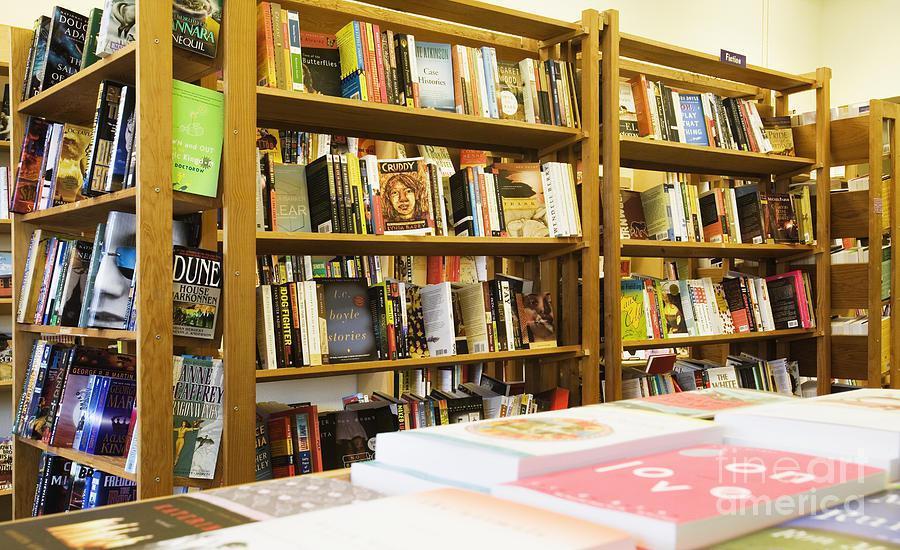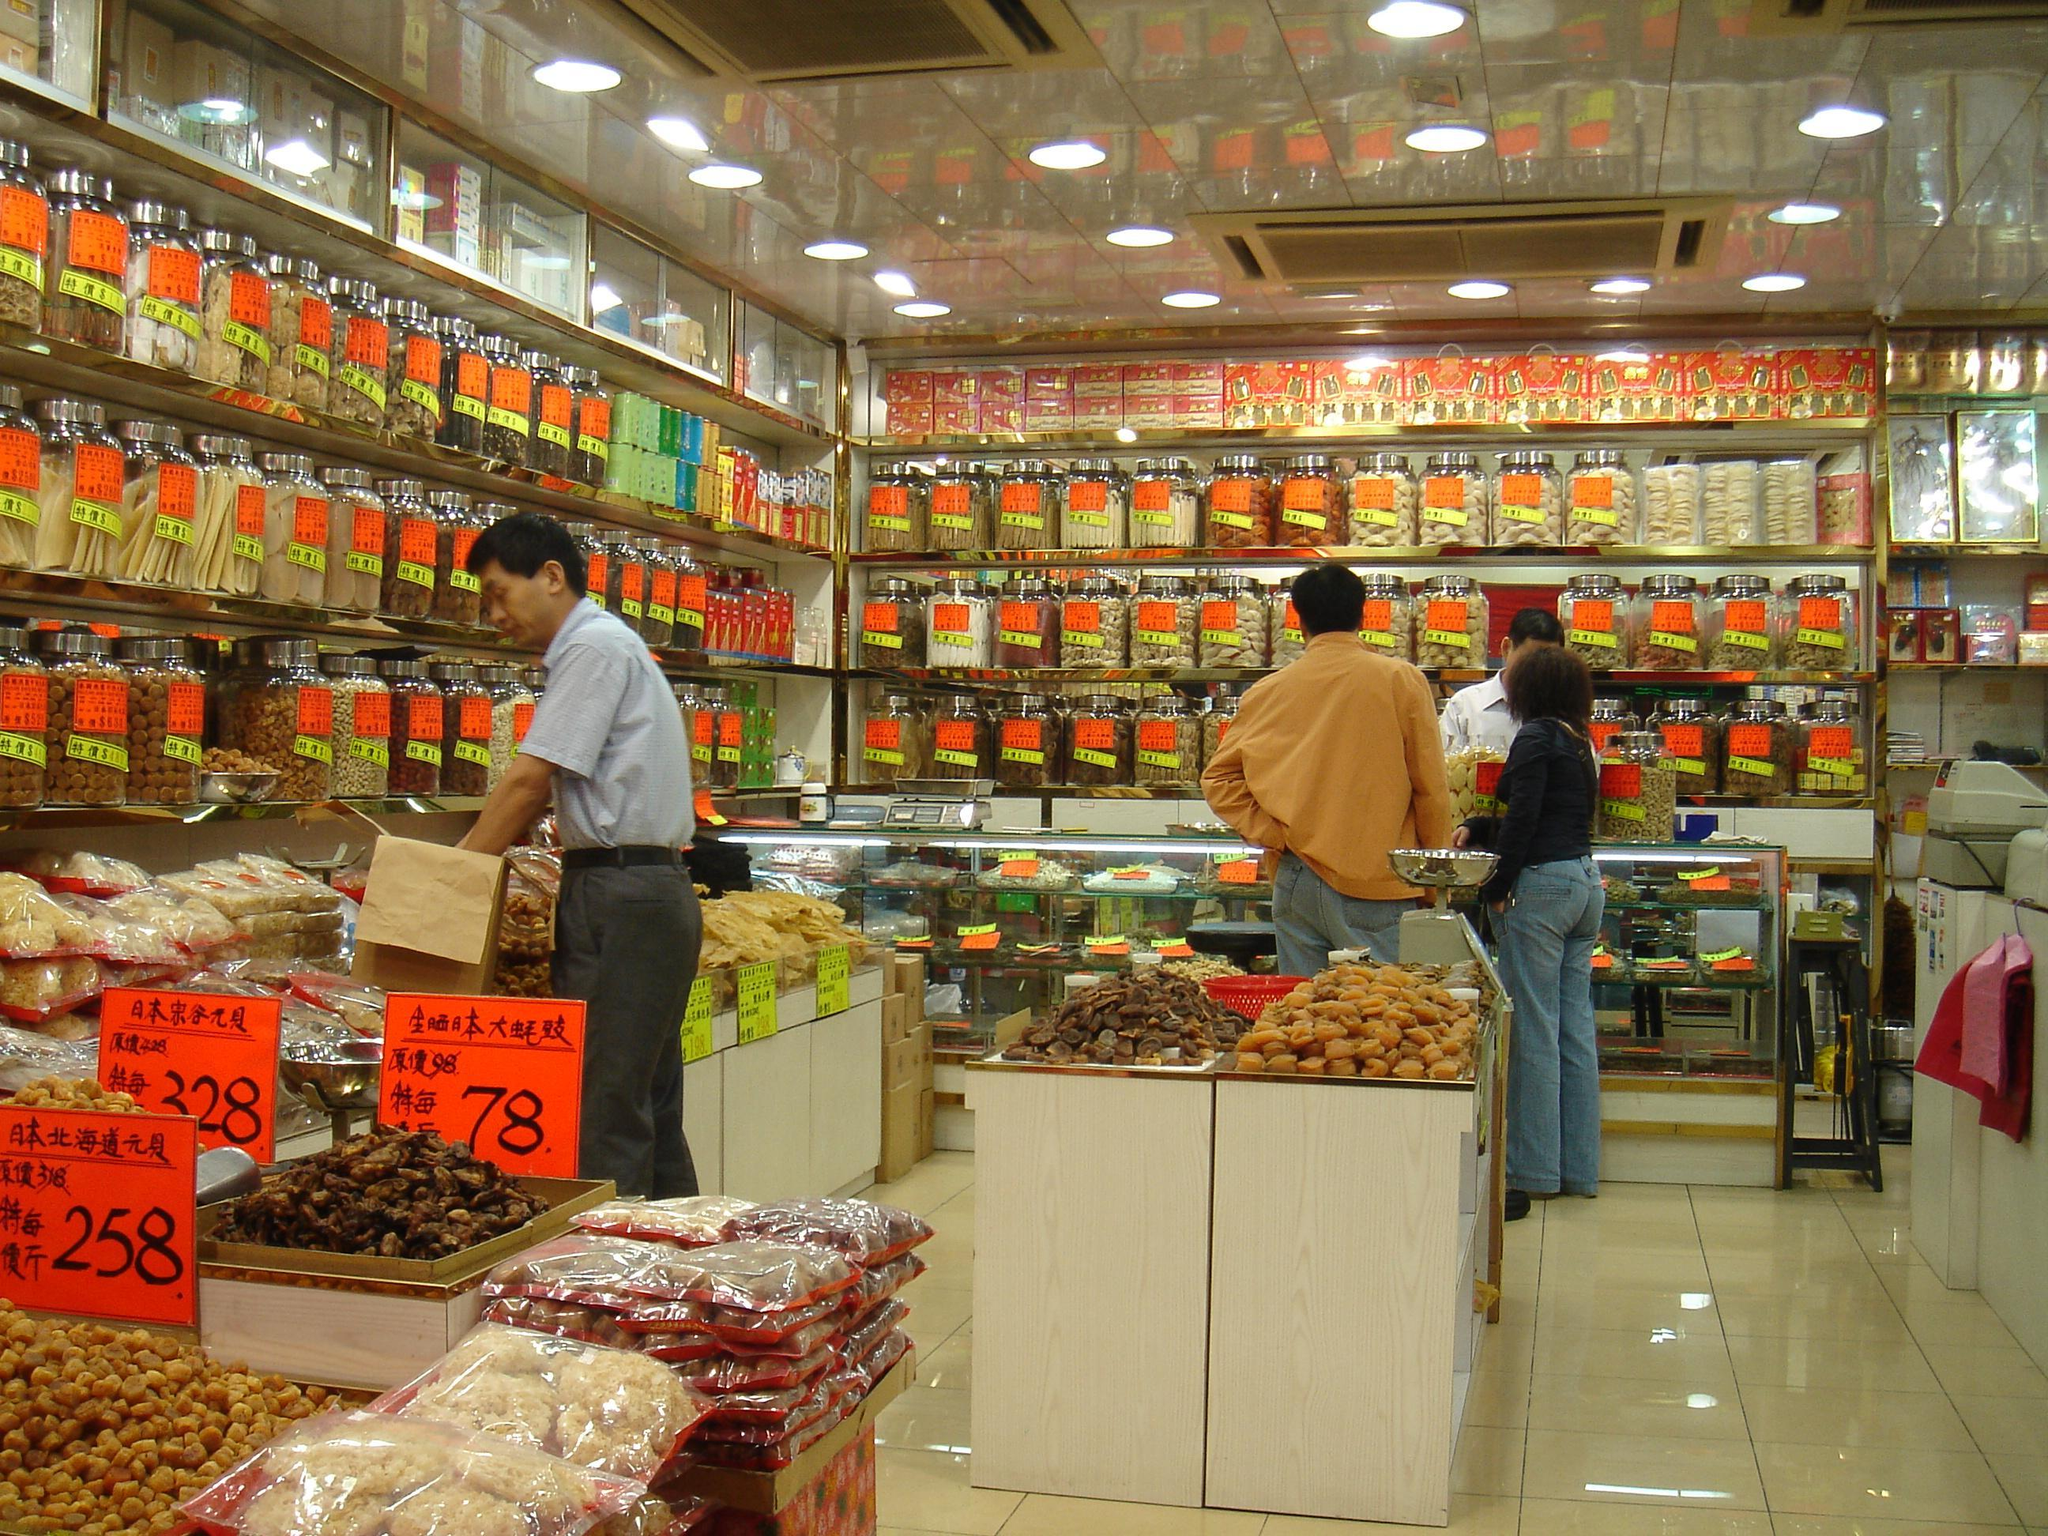The first image is the image on the left, the second image is the image on the right. Given the left and right images, does the statement "There are books on a table." hold true? Answer yes or no. Yes. The first image is the image on the left, the second image is the image on the right. For the images displayed, is the sentence "In the left image, books stacked flat are in front of books upright on rows of light-colored wood shelves, while the right image shows a variety of non-book items filling shelves on the walls." factually correct? Answer yes or no. Yes. 